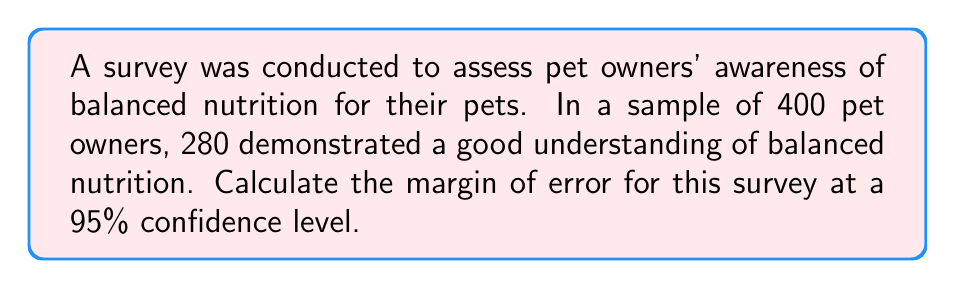Show me your answer to this math problem. To calculate the margin of error, we'll follow these steps:

1. Identify the given information:
   - Sample size (n) = 400
   - Number of successes (x) = 280
   - Confidence level = 95%

2. Calculate the sample proportion (p̂):
   $$\hat{p} = \frac{x}{n} = \frac{280}{400} = 0.7$$

3. Find the z-score for a 95% confidence level:
   The z-score for a 95% confidence level is 1.96.

4. Calculate the standard error (SE):
   $$SE = \sqrt{\frac{\hat{p}(1-\hat{p})}{n}}$$
   $$SE = \sqrt{\frac{0.7(1-0.7)}{400}} = \sqrt{\frac{0.21}{400}} = 0.0229$$

5. Compute the margin of error (MOE):
   $$MOE = z \times SE$$
   $$MOE = 1.96 \times 0.0229 = 0.0449$$

6. Convert to percentage:
   $$MOE(\%) = 0.0449 \times 100\% = 4.49\%$$

The margin of error for this survey is approximately 4.49%.
Answer: 4.49% 